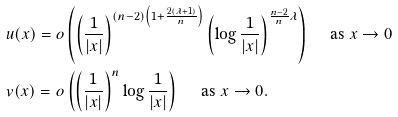<formula> <loc_0><loc_0><loc_500><loc_500>& u ( x ) = o \left ( \left ( \frac { 1 } { | x | } \right ) ^ { ( n - 2 ) \left ( 1 + \frac { 2 ( \lambda + 1 ) } { n } \right ) } \left ( \log \frac { 1 } { | x | } \right ) ^ { \frac { n - 2 } { n } \lambda } \right ) \quad \text { as } x \to 0 \\ & v ( x ) = o \left ( \left ( \frac { 1 } { | x | } \right ) ^ { n } \log \frac { 1 } { | x | } \right ) \quad \text { as } x \to 0 .</formula> 